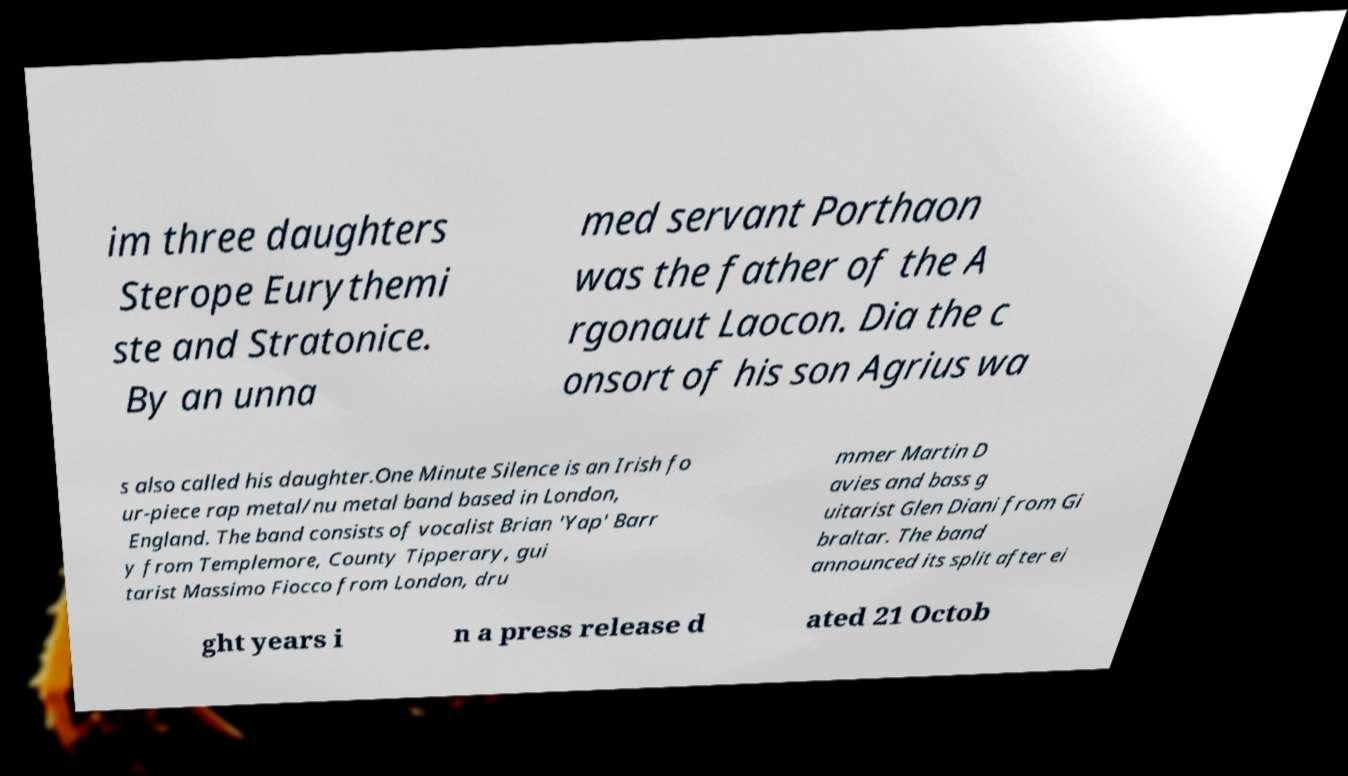Can you read and provide the text displayed in the image?This photo seems to have some interesting text. Can you extract and type it out for me? im three daughters Sterope Eurythemi ste and Stratonice. By an unna med servant Porthaon was the father of the A rgonaut Laocon. Dia the c onsort of his son Agrius wa s also called his daughter.One Minute Silence is an Irish fo ur-piece rap metal/nu metal band based in London, England. The band consists of vocalist Brian 'Yap' Barr y from Templemore, County Tipperary, gui tarist Massimo Fiocco from London, dru mmer Martin D avies and bass g uitarist Glen Diani from Gi braltar. The band announced its split after ei ght years i n a press release d ated 21 Octob 